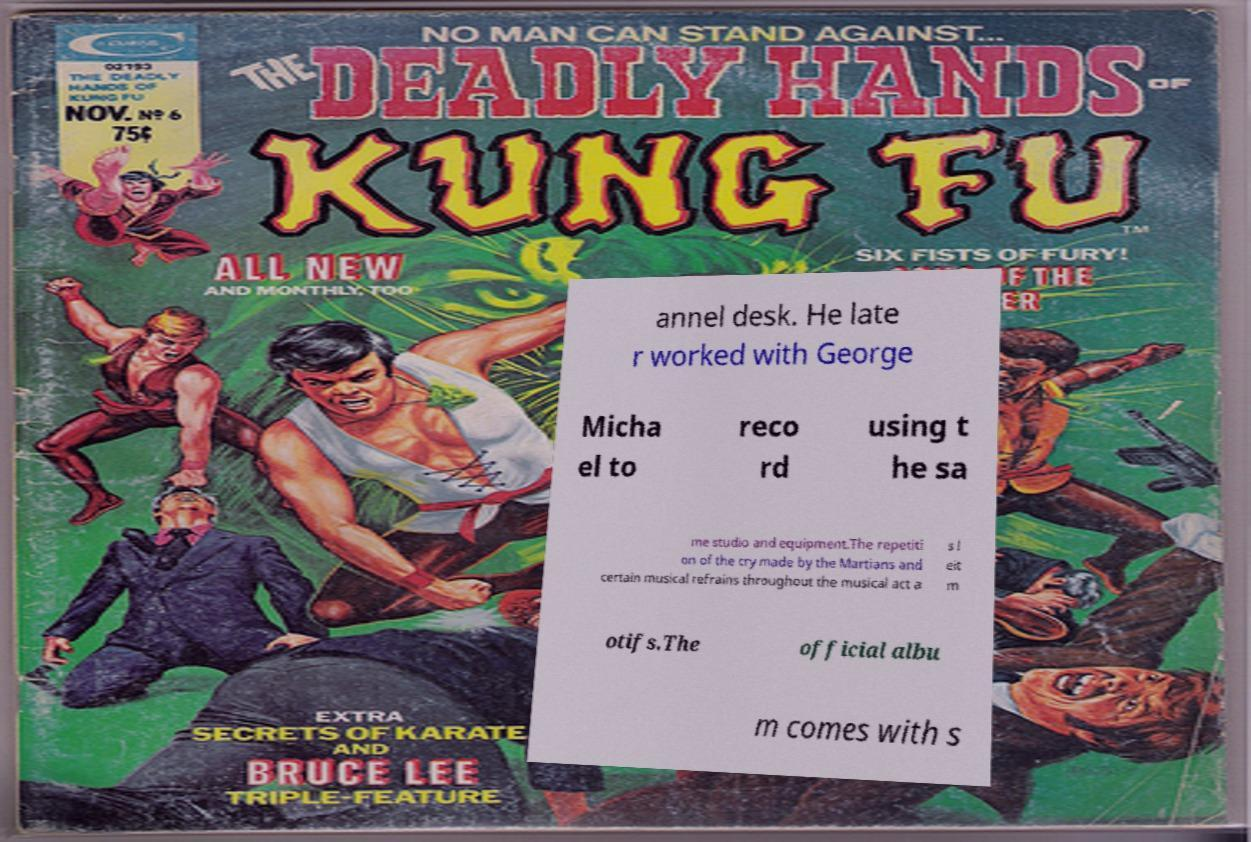Could you assist in decoding the text presented in this image and type it out clearly? annel desk. He late r worked with George Micha el to reco rd using t he sa me studio and equipment.The repetiti on of the cry made by the Martians and certain musical refrains throughout the musical act a s l eit m otifs.The official albu m comes with s 